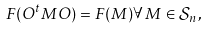<formula> <loc_0><loc_0><loc_500><loc_500>F ( O ^ { t } M O ) = F ( M ) \forall \, M \in { \mathcal { S } } _ { n } \, ,</formula> 